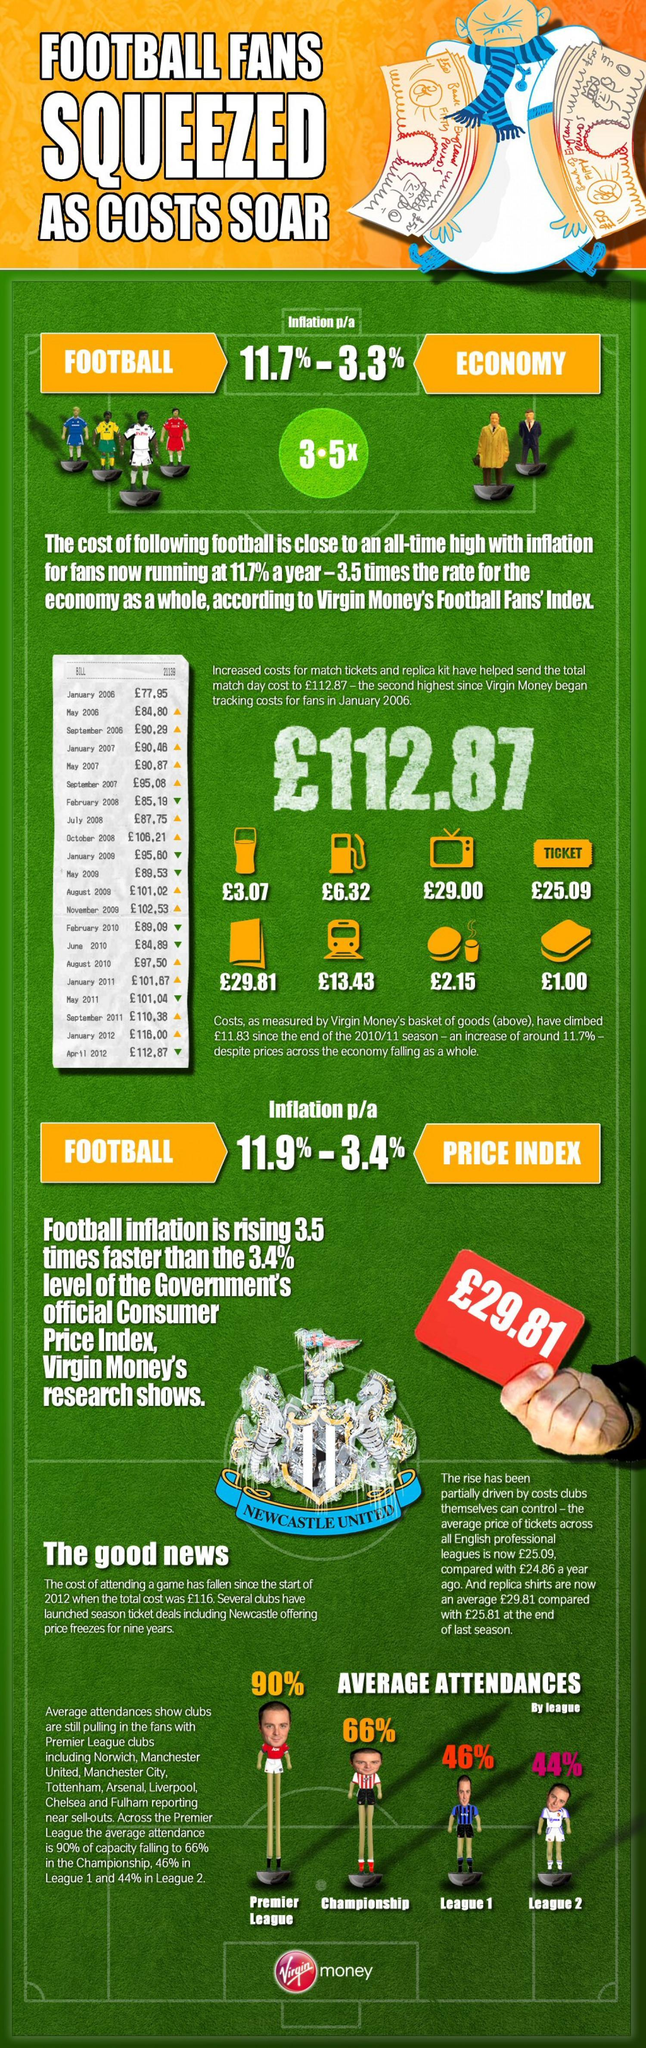How many premier league clubs mentioned in this infographic?
Answer the question with a short phrase. 8 